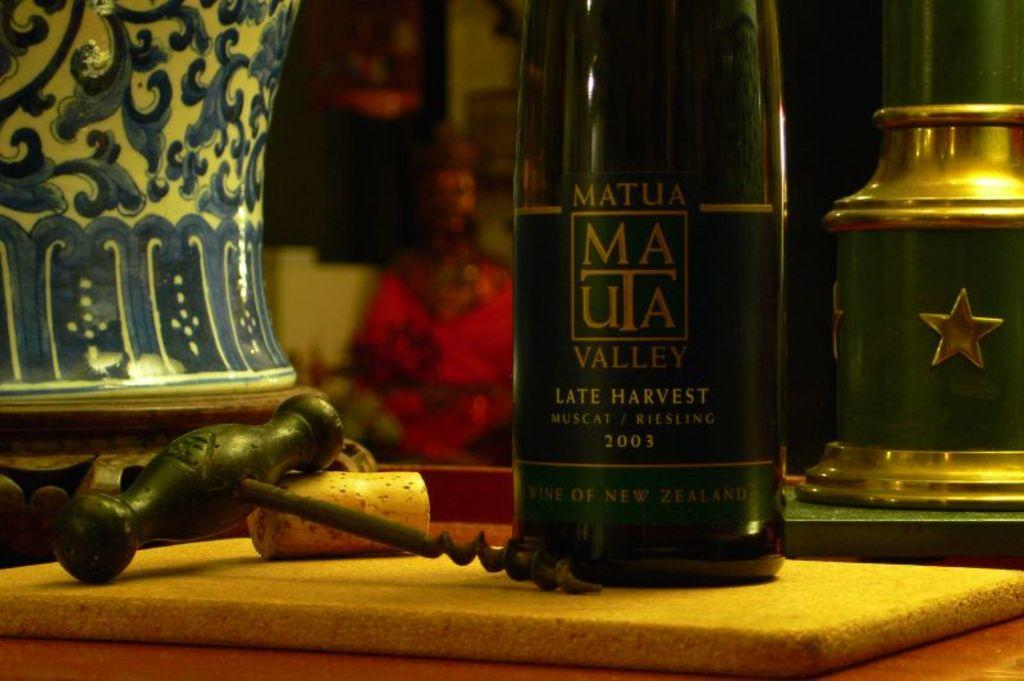Provide a one-sentence caption for the provided image. A bottle of Matua Valley from New Zealand sits next to a corkscrew. 